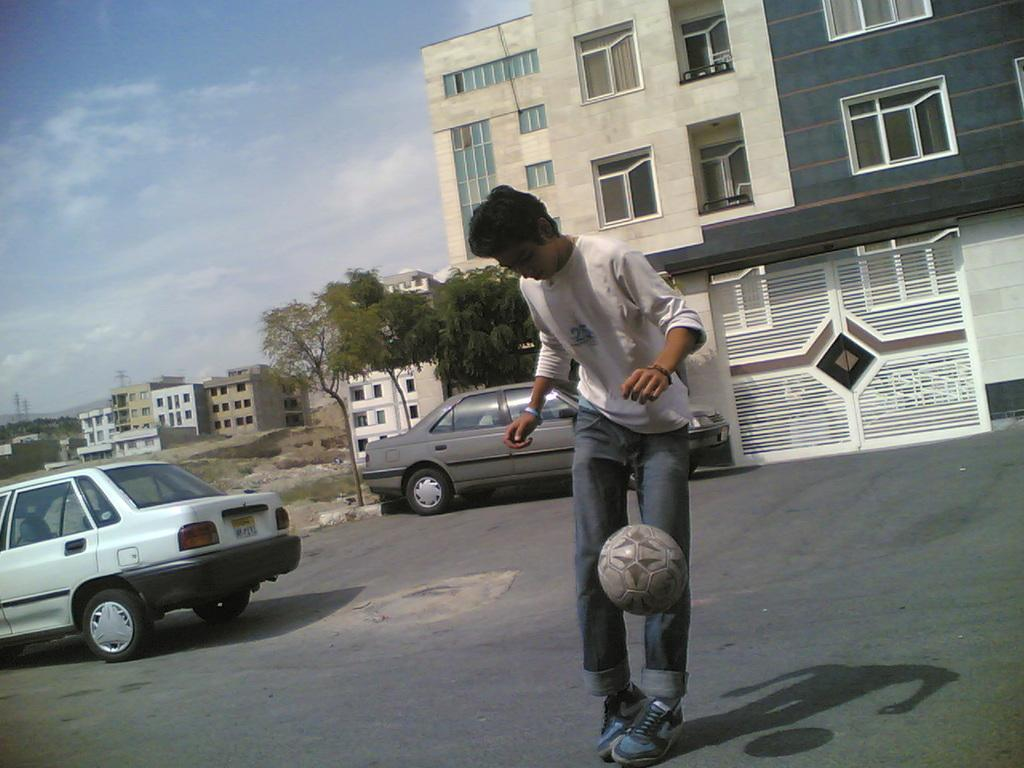What is the man in the image doing? The man is playing football in the image. Where is the man playing football? The man is on the road. What can be seen in the background of the image? There are buildings, two cars, trees, and the sky visible in the background of the image. What is the condition of the sky in the image? The sky is visible in the background of the image, and clouds are present. What type of plastic material is being used to comfort the man while playing football in the image? There is no plastic material being used to comfort the man in the image; he is playing football on the road. 